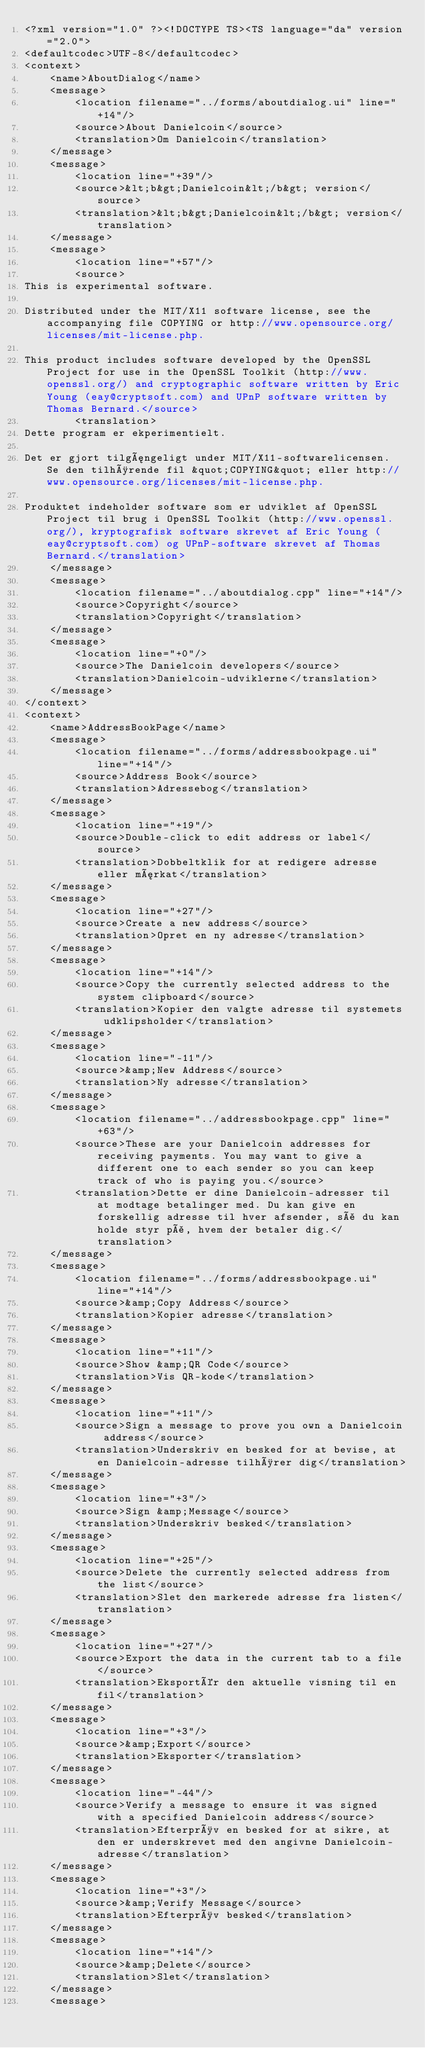<code> <loc_0><loc_0><loc_500><loc_500><_TypeScript_><?xml version="1.0" ?><!DOCTYPE TS><TS language="da" version="2.0">
<defaultcodec>UTF-8</defaultcodec>
<context>
    <name>AboutDialog</name>
    <message>
        <location filename="../forms/aboutdialog.ui" line="+14"/>
        <source>About Danielcoin</source>
        <translation>Om Danielcoin</translation>
    </message>
    <message>
        <location line="+39"/>
        <source>&lt;b&gt;Danielcoin&lt;/b&gt; version</source>
        <translation>&lt;b&gt;Danielcoin&lt;/b&gt; version</translation>
    </message>
    <message>
        <location line="+57"/>
        <source>
This is experimental software.

Distributed under the MIT/X11 software license, see the accompanying file COPYING or http://www.opensource.org/licenses/mit-license.php.

This product includes software developed by the OpenSSL Project for use in the OpenSSL Toolkit (http://www.openssl.org/) and cryptographic software written by Eric Young (eay@cryptsoft.com) and UPnP software written by Thomas Bernard.</source>
        <translation>
Dette program er ekperimentielt.

Det er gjort tilgængeligt under MIT/X11-softwarelicensen. Se den tilhørende fil &quot;COPYING&quot; eller http://www.opensource.org/licenses/mit-license.php.

Produktet indeholder software som er udviklet af OpenSSL Project til brug i OpenSSL Toolkit (http://www.openssl.org/), kryptografisk software skrevet af Eric Young (eay@cryptsoft.com) og UPnP-software skrevet af Thomas Bernard.</translation>
    </message>
    <message>
        <location filename="../aboutdialog.cpp" line="+14"/>
        <source>Copyright</source>
        <translation>Copyright</translation>
    </message>
    <message>
        <location line="+0"/>
        <source>The Danielcoin developers</source>
        <translation>Danielcoin-udviklerne</translation>
    </message>
</context>
<context>
    <name>AddressBookPage</name>
    <message>
        <location filename="../forms/addressbookpage.ui" line="+14"/>
        <source>Address Book</source>
        <translation>Adressebog</translation>
    </message>
    <message>
        <location line="+19"/>
        <source>Double-click to edit address or label</source>
        <translation>Dobbeltklik for at redigere adresse eller mærkat</translation>
    </message>
    <message>
        <location line="+27"/>
        <source>Create a new address</source>
        <translation>Opret en ny adresse</translation>
    </message>
    <message>
        <location line="+14"/>
        <source>Copy the currently selected address to the system clipboard</source>
        <translation>Kopier den valgte adresse til systemets udklipsholder</translation>
    </message>
    <message>
        <location line="-11"/>
        <source>&amp;New Address</source>
        <translation>Ny adresse</translation>
    </message>
    <message>
        <location filename="../addressbookpage.cpp" line="+63"/>
        <source>These are your Danielcoin addresses for receiving payments. You may want to give a different one to each sender so you can keep track of who is paying you.</source>
        <translation>Dette er dine Danielcoin-adresser til at modtage betalinger med. Du kan give en forskellig adresse til hver afsender, så du kan holde styr på, hvem der betaler dig.</translation>
    </message>
    <message>
        <location filename="../forms/addressbookpage.ui" line="+14"/>
        <source>&amp;Copy Address</source>
        <translation>Kopier adresse</translation>
    </message>
    <message>
        <location line="+11"/>
        <source>Show &amp;QR Code</source>
        <translation>Vis QR-kode</translation>
    </message>
    <message>
        <location line="+11"/>
        <source>Sign a message to prove you own a Danielcoin address</source>
        <translation>Underskriv en besked for at bevise, at en Danielcoin-adresse tilhører dig</translation>
    </message>
    <message>
        <location line="+3"/>
        <source>Sign &amp;Message</source>
        <translation>Underskriv besked</translation>
    </message>
    <message>
        <location line="+25"/>
        <source>Delete the currently selected address from the list</source>
        <translation>Slet den markerede adresse fra listen</translation>
    </message>
    <message>
        <location line="+27"/>
        <source>Export the data in the current tab to a file</source>
        <translation>Eksportér den aktuelle visning til en fil</translation>
    </message>
    <message>
        <location line="+3"/>
        <source>&amp;Export</source>
        <translation>Eksporter</translation>
    </message>
    <message>
        <location line="-44"/>
        <source>Verify a message to ensure it was signed with a specified Danielcoin address</source>
        <translation>Efterprøv en besked for at sikre, at den er underskrevet med den angivne Danielcoin-adresse</translation>
    </message>
    <message>
        <location line="+3"/>
        <source>&amp;Verify Message</source>
        <translation>Efterprøv besked</translation>
    </message>
    <message>
        <location line="+14"/>
        <source>&amp;Delete</source>
        <translation>Slet</translation>
    </message>
    <message></code> 